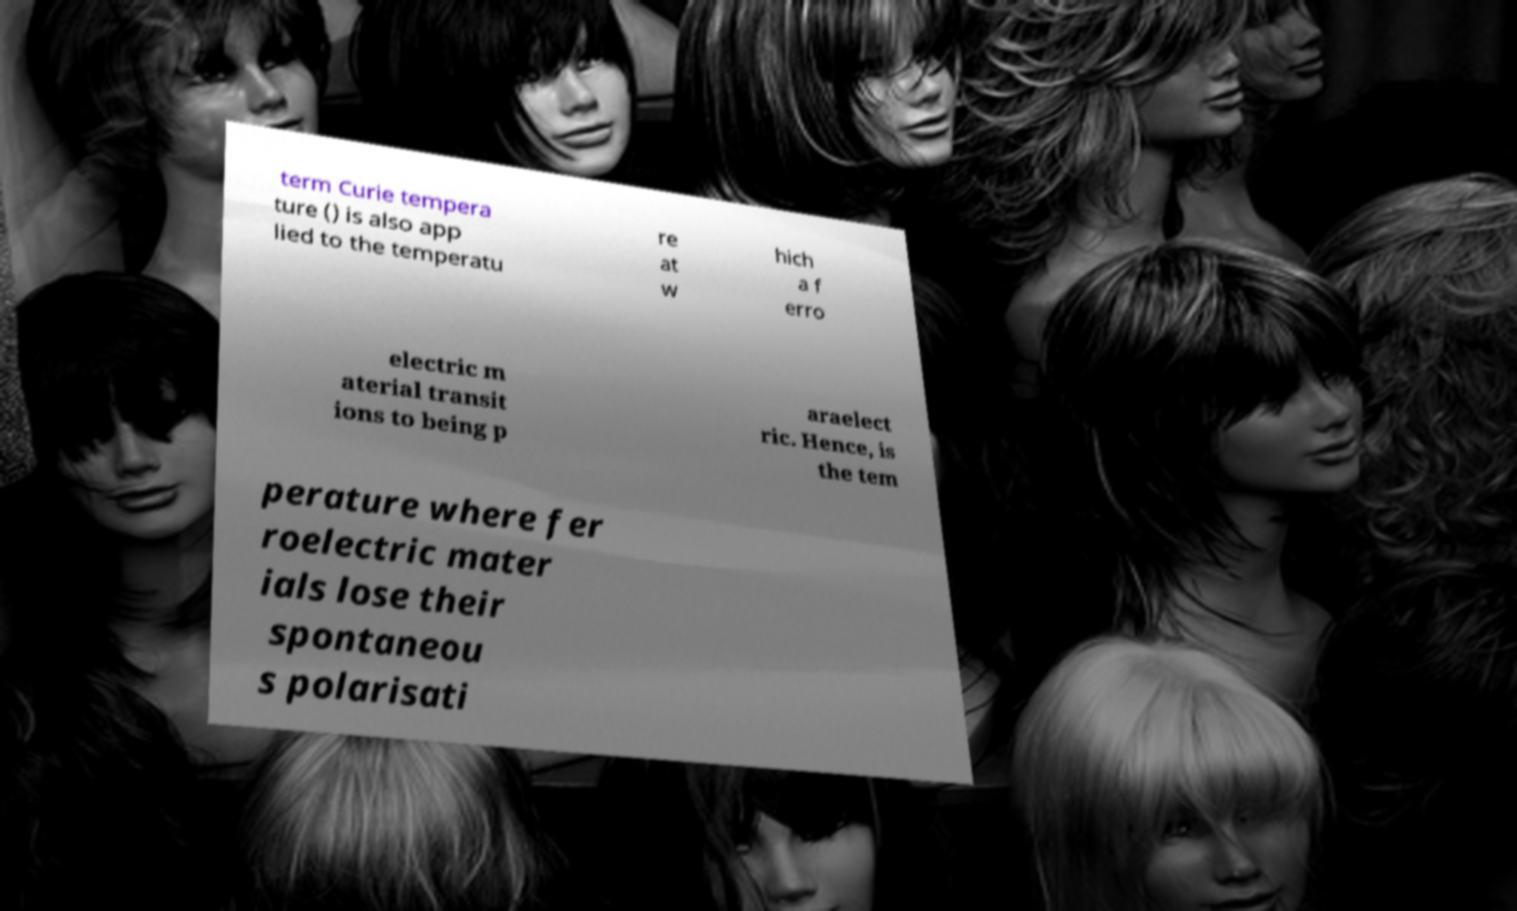Could you assist in decoding the text presented in this image and type it out clearly? term Curie tempera ture () is also app lied to the temperatu re at w hich a f erro electric m aterial transit ions to being p araelect ric. Hence, is the tem perature where fer roelectric mater ials lose their spontaneou s polarisati 